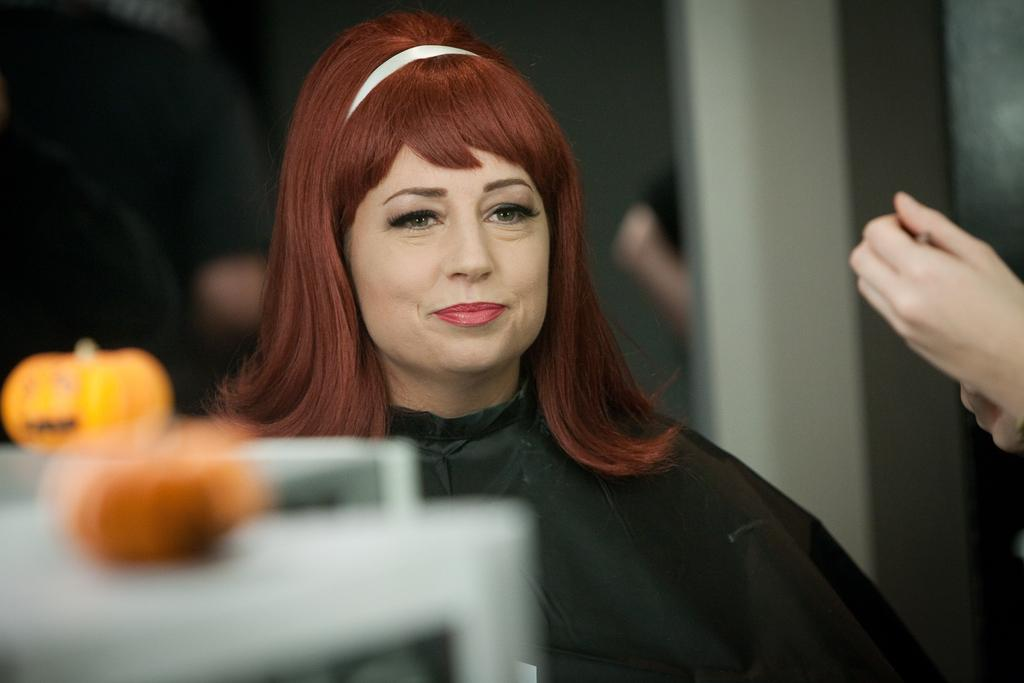Who is present in the image? There is a woman in the image. What part of a person can be seen in the image? There is a hand of a person in the image. What else can be seen in the image besides the woman and the hand? There are objects in the image. Can you describe the background of the image? The background of the image is blurred. What time of day is depicted in the image? The time of day cannot be determined from the image, as there are no specific clues or indicators present. 